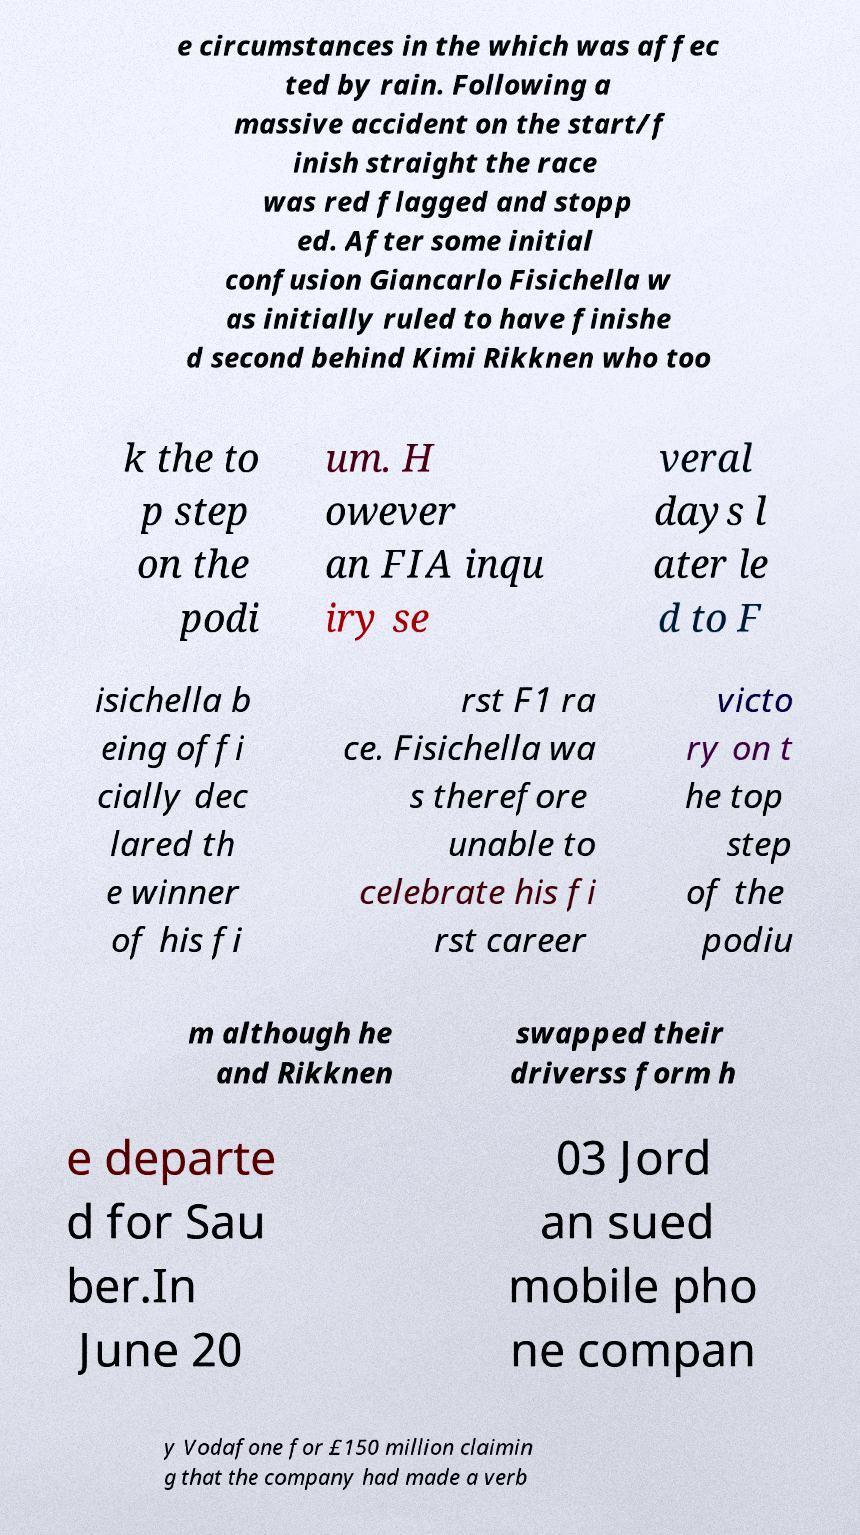Can you accurately transcribe the text from the provided image for me? e circumstances in the which was affec ted by rain. Following a massive accident on the start/f inish straight the race was red flagged and stopp ed. After some initial confusion Giancarlo Fisichella w as initially ruled to have finishe d second behind Kimi Rikknen who too k the to p step on the podi um. H owever an FIA inqu iry se veral days l ater le d to F isichella b eing offi cially dec lared th e winner of his fi rst F1 ra ce. Fisichella wa s therefore unable to celebrate his fi rst career victo ry on t he top step of the podiu m although he and Rikknen swapped their driverss form h e departe d for Sau ber.In June 20 03 Jord an sued mobile pho ne compan y Vodafone for £150 million claimin g that the company had made a verb 